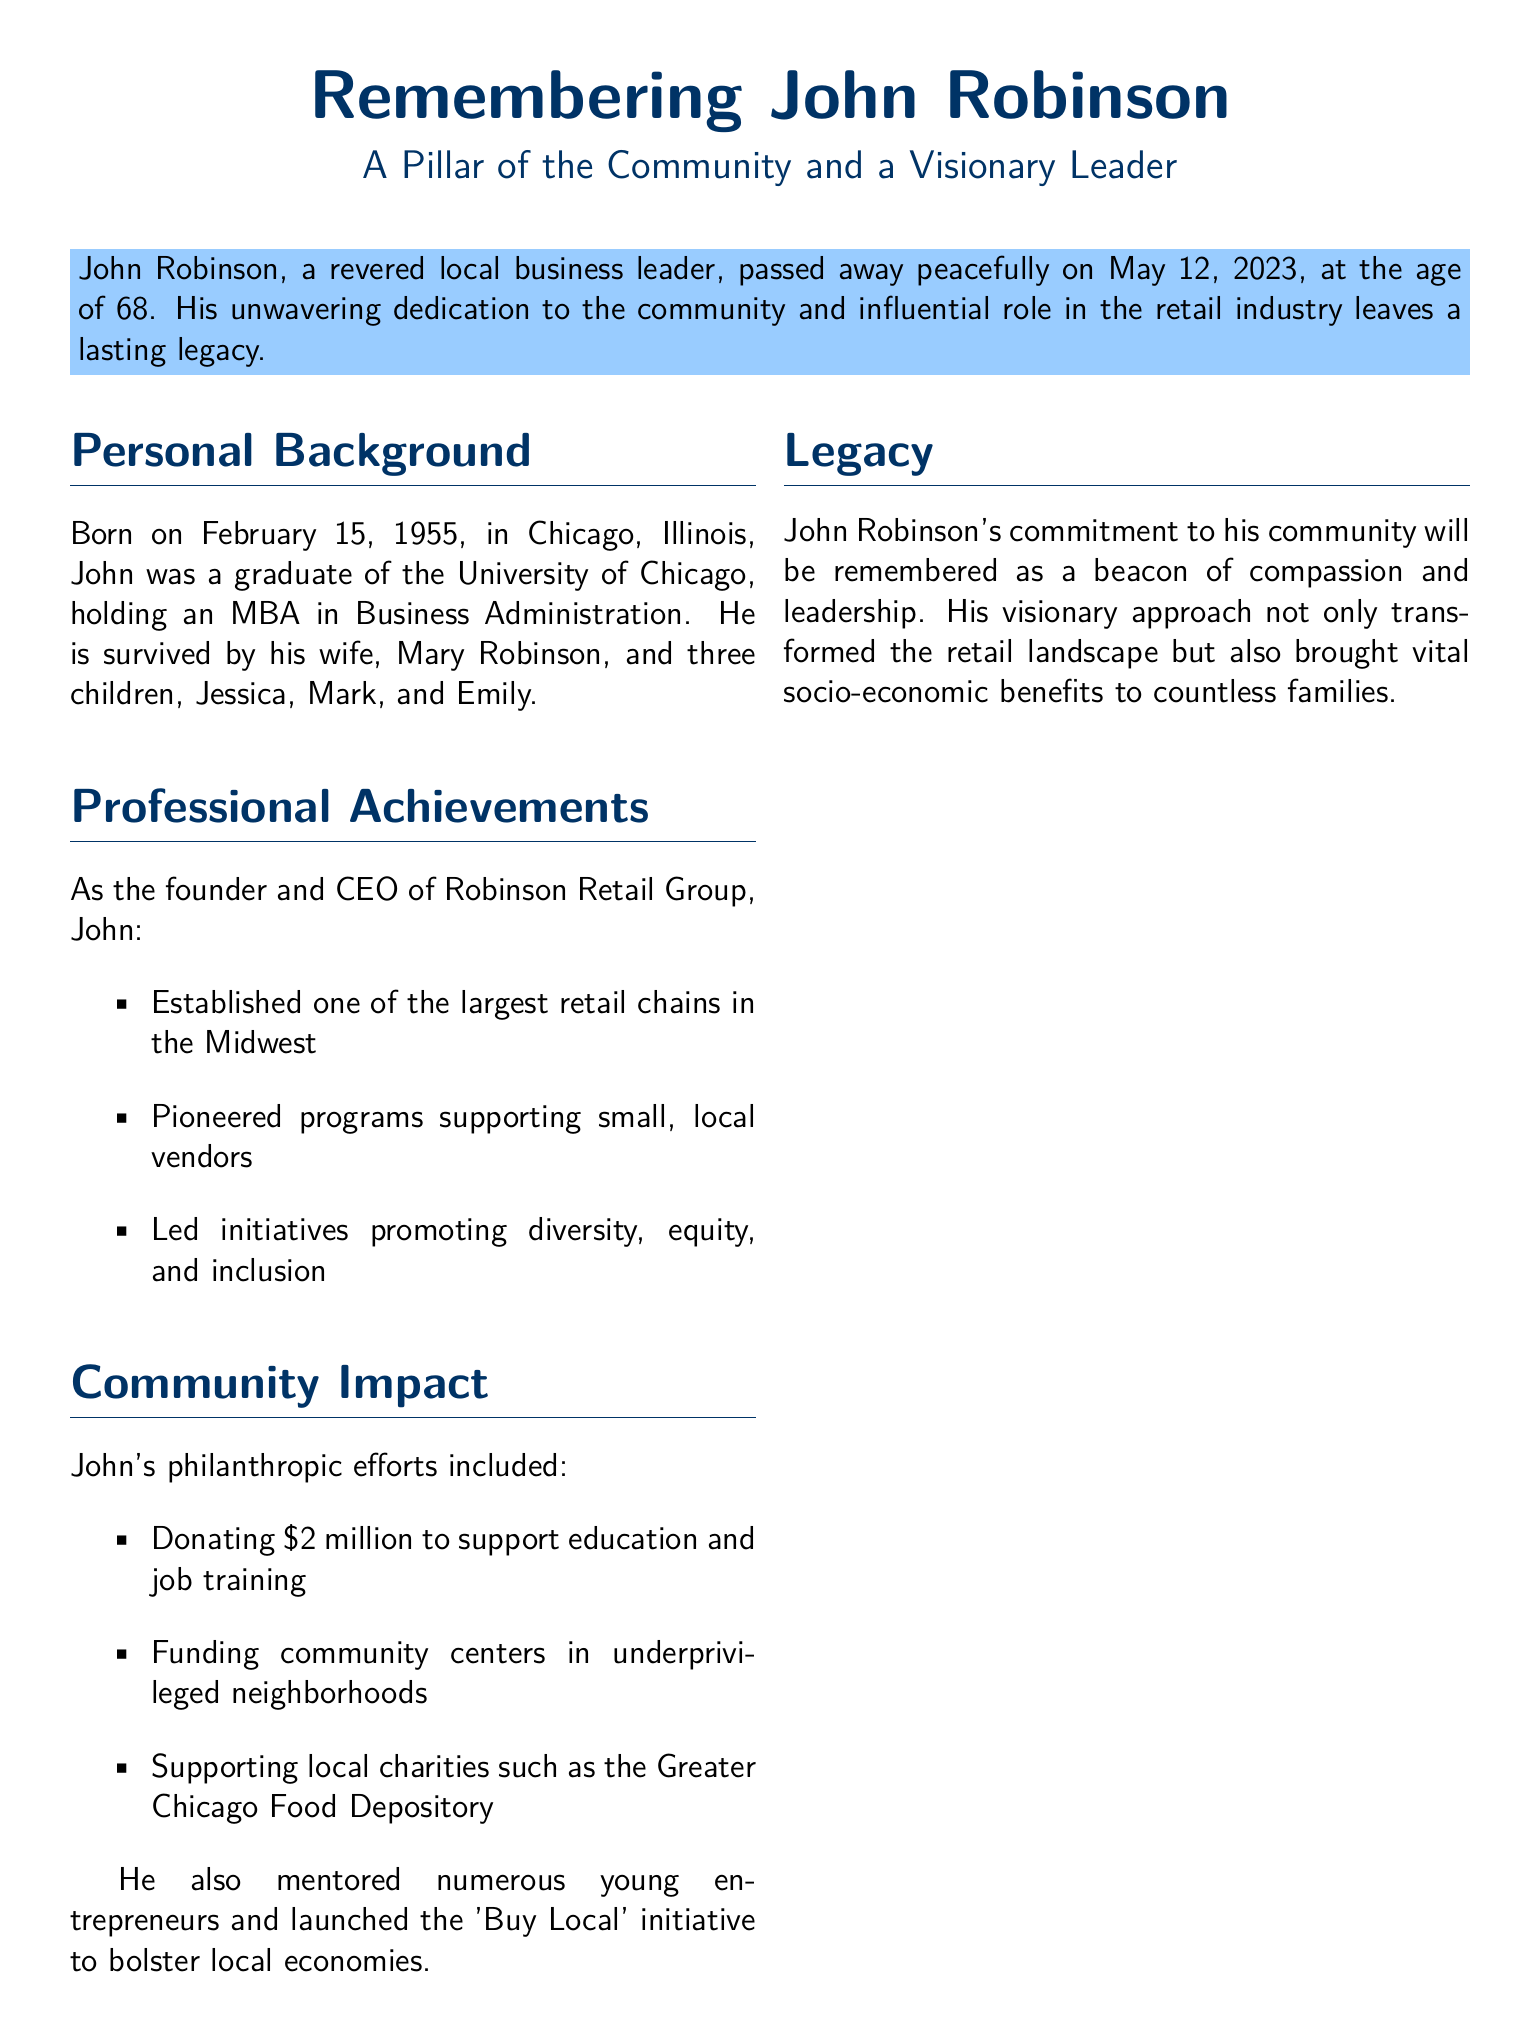What was John Robinson's role in the retail industry? John Robinson was the founder and CEO of Robinson Retail Group, indicating his high leadership position in the retail industry.
Answer: founder and CEO of Robinson Retail Group What amount did John Robinson donate to support education and job training? The document states that he donated $2 million specifically for education and job training efforts in the community.
Answer: $2 million When was John Robinson born? His birth date is mentioned as February 15, 1955, in the personal background section of the document.
Answer: February 15, 1955 Who survived John Robinson? The document lists his wife and children, which includes Mary Robinson and three children named Jessica, Mark, and Emily.
Answer: Mary Robinson, Jessica, Mark, and Emily What initiative did John Robinson launch to help local economies? The document describes his 'Buy Local' initiative that was aimed at bolstering local economies, emphasizing his support for local businesses.
Answer: 'Buy Local' initiative What did John Robinson's leadership promote, aside from retail successes? His professional achievements highlighted initiatives promoting diversity, equity, and inclusion, suggesting a broader impact beyond retail.
Answer: diversity, equity, and inclusion Who stated, "John believed in the potential of every individual"? Jane Doe is credited with this tribute, reflecting on John Robinson's mentoring qualities in the community.
Answer: Jane Doe What was the final year of John Robinson's life? The document mentions his passing in the year 2023, which is crucial to understanding the timeframe of his legacy.
Answer: 2023 